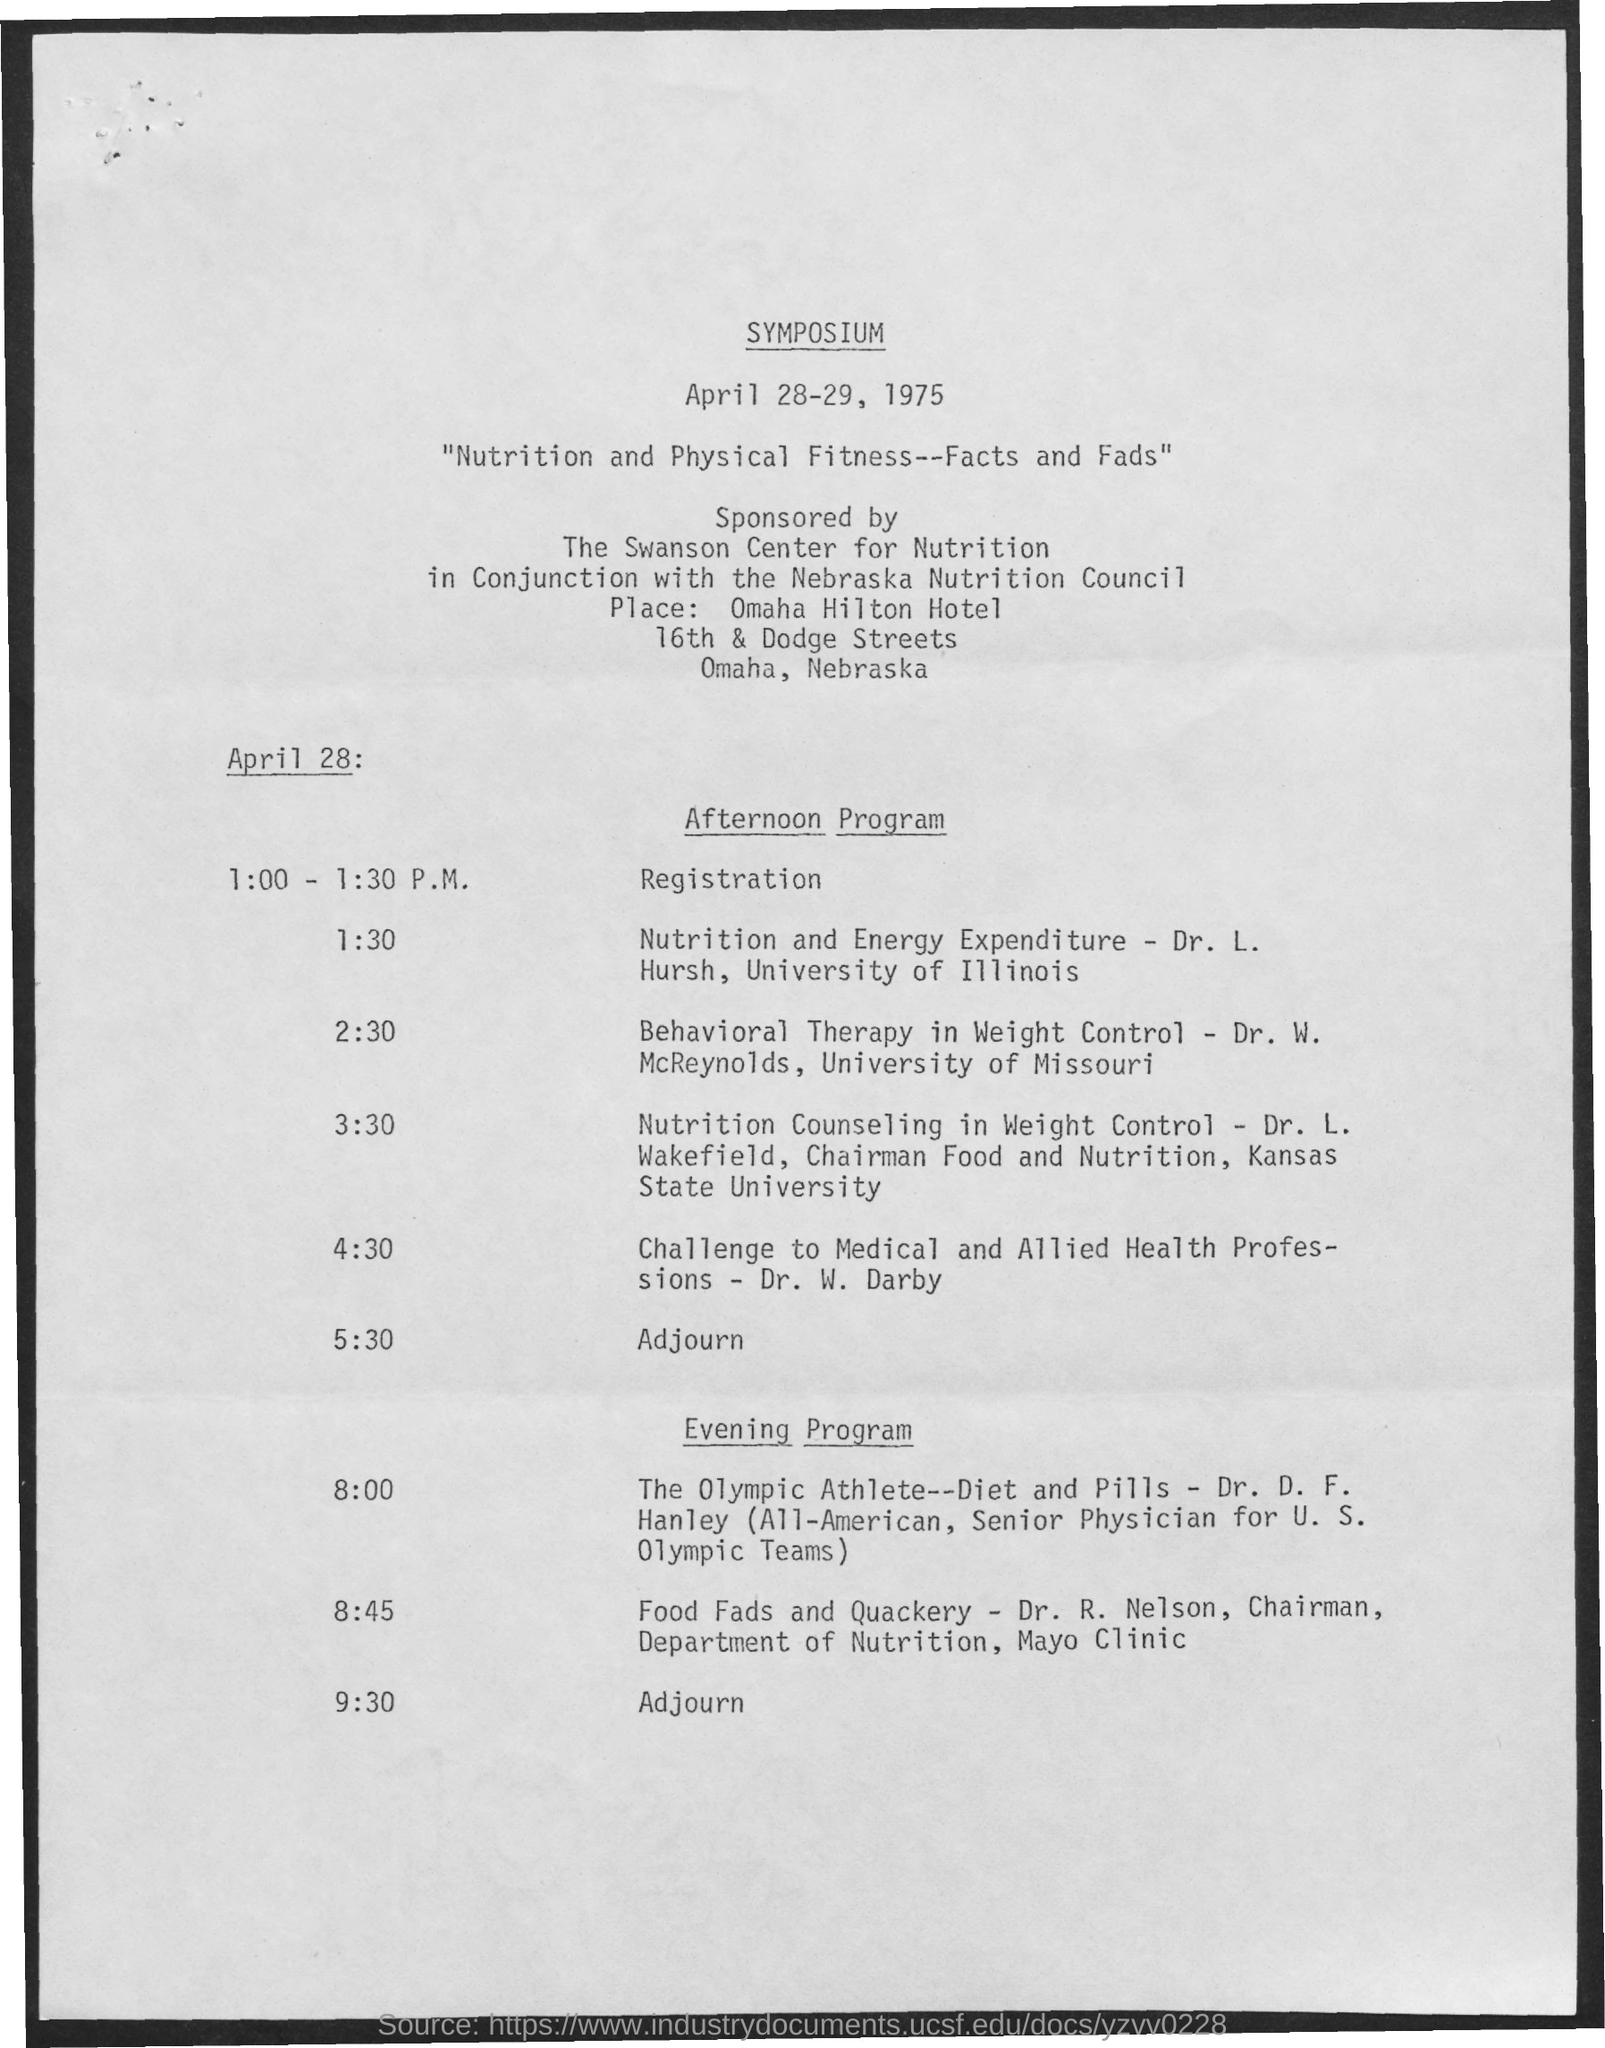Draw attention to some important aspects in this diagram. The date mentioned is April 28-29, 1975. At 1:00 - 1:30 p.m. on April 28, the schedule will be in effect. 